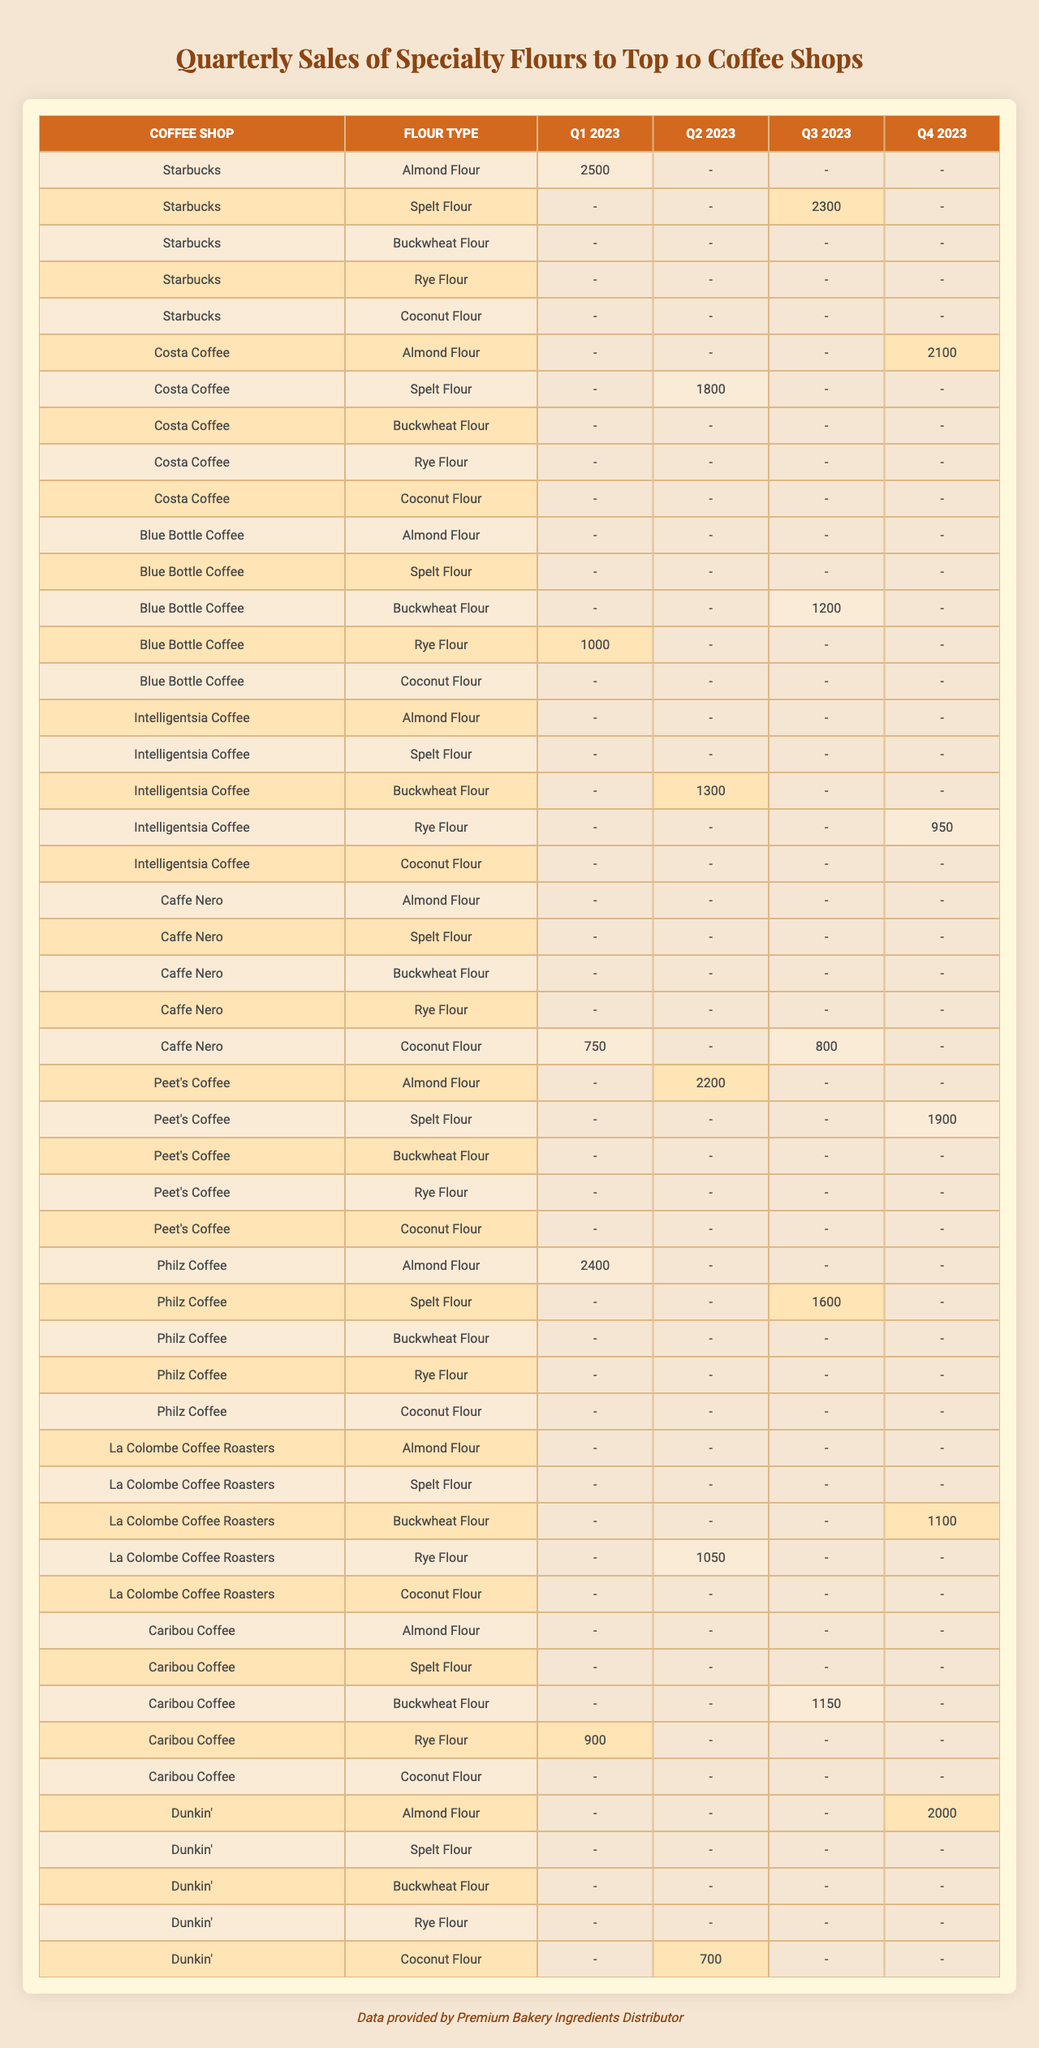What was the highest sales amount for Almond Flour in Q1 2023? Looking at the table, Starbucks sold 2500 of Almond Flour in Q1 2023, which is the only entry for that flour in that quarter.
Answer: 2500 Which coffee shop had the lowest sales of Coconut Flour for any quarter? In the table, Dunkin' sold the lowest amount of Coconut Flour, with 700 in Q2 2023.
Answer: Dunkin' What was the combined sales of Spelt Flour for Peet's Coffee in Q2 2023 and Q4 2023? Peet's Coffee sold 2200 of Almond Flour in Q2 2023 and 1900 of Spelt Flour in Q4 2023. Adding these together gives 2200 + 1900 = 4100. However, only Spelt Flour was asked, therefore the result would be 0 since there are no records of Spelt Flour sales by Peet's Coffee for the referenced quarters.
Answer: 0 Was there any quarter where Blue Bottle Coffee sold more than 1000 of Buckwheat Flour? According to the table, Blue Bottle Coffee sold 1200 of Buckwheat Flour in Q3 2023, which is greater than 1000.
Answer: Yes What is the total sales of Rye Flour across all coffee shops in Q1 2023? In Q1 2023, only Blue Bottle Coffee sold 1000 of Rye Flour. So the total sales is 1000.
Answer: 1000 In which quarter did Caffe Nero have the highest sales of any flour type? Caffe Nero had 750 of Coconut Flour in Q1 2023, 800 of Coconut Flour in Q3 2023, and no other flour recorded higher than 800. Thus, the highest sales occurred in Q3 2023.
Answer: Q3 2023 How many coffee shops had sales for Coconut Flour in Q4 2023? Only Dunkin' had sales of 2000 of Coconut Flour in Q4 2023, making it the only shop for that flour in the specified quarter.
Answer: 1 What flour did Intelligentsia Coffee sell more of in Q4 2023 compared to Q3 2023? In Q4 2023, Intelligentsia Coffee sold 950 of Rye Flour, whereas in Q3 2023 they had no sales recorded for any flour type. Comparing these amounts, it can be concluded that they sold more in Q4 2023 since they had no sales in Q3.
Answer: Q4 2023 Which quarter had the highest sales of Buckwheat Flour across all shops? In the table, the highest sales of Buckwheat Flour is 1200 from Blue Bottle Coffee in Q3 2023, with no other sales higher than that for Buckwheat Flour in any quarter.
Answer: Q3 2023 What was the total amount of Almond Flour sold across all coffee shops in Q2 2023? In Q2 2023, there are no sales recorded for Almond Flour; therefore, the total would be 0.
Answer: 0 